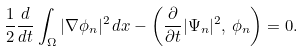<formula> <loc_0><loc_0><loc_500><loc_500>\frac { 1 } { 2 } \frac { d } { d t } \int _ { \Omega } | \nabla \phi _ { n } | ^ { 2 } \, d x - \left ( \frac { \partial } { \partial t } | \Psi _ { n } | ^ { 2 } , \, \phi _ { n } \right ) = 0 .</formula> 